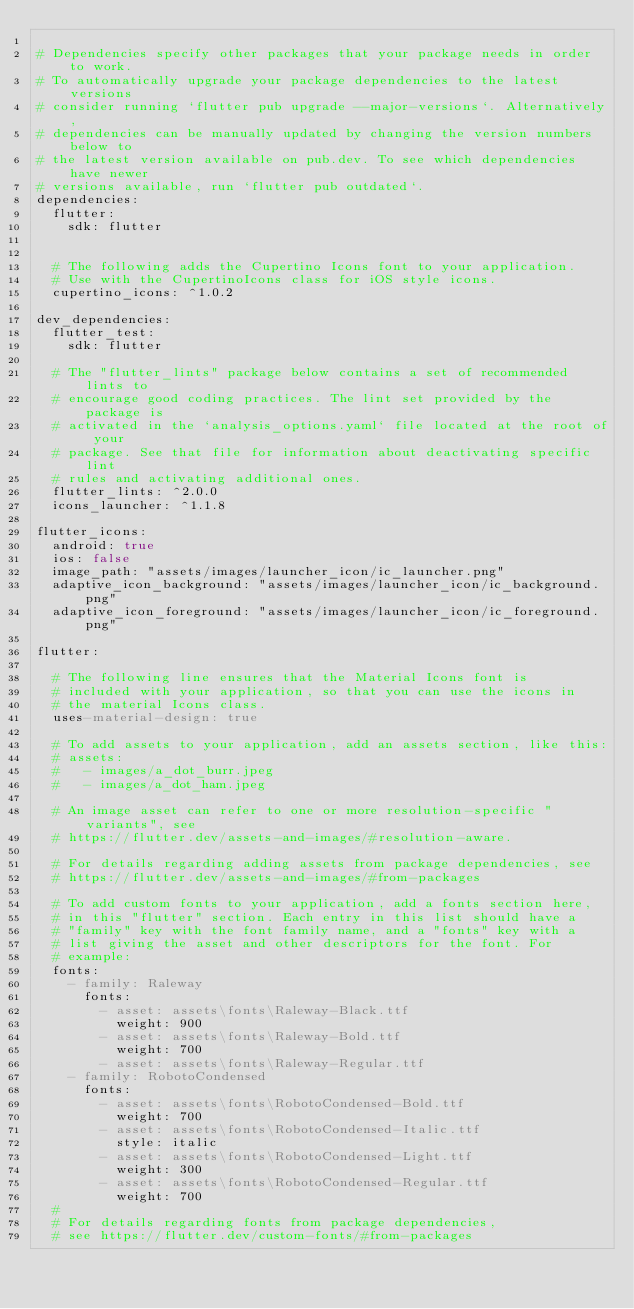Convert code to text. <code><loc_0><loc_0><loc_500><loc_500><_YAML_>
# Dependencies specify other packages that your package needs in order to work.
# To automatically upgrade your package dependencies to the latest versions
# consider running `flutter pub upgrade --major-versions`. Alternatively,
# dependencies can be manually updated by changing the version numbers below to
# the latest version available on pub.dev. To see which dependencies have newer
# versions available, run `flutter pub outdated`.
dependencies:
  flutter:
    sdk: flutter


  # The following adds the Cupertino Icons font to your application.
  # Use with the CupertinoIcons class for iOS style icons.
  cupertino_icons: ^1.0.2

dev_dependencies:
  flutter_test:
    sdk: flutter

  # The "flutter_lints" package below contains a set of recommended lints to
  # encourage good coding practices. The lint set provided by the package is
  # activated in the `analysis_options.yaml` file located at the root of your
  # package. See that file for information about deactivating specific lint
  # rules and activating additional ones.
  flutter_lints: ^2.0.0
  icons_launcher: ^1.1.8

flutter_icons:
  android: true
  ios: false
  image_path: "assets/images/launcher_icon/ic_launcher.png"
  adaptive_icon_background: "assets/images/launcher_icon/ic_background.png"
  adaptive_icon_foreground: "assets/images/launcher_icon/ic_foreground.png"

flutter:

  # The following line ensures that the Material Icons font is
  # included with your application, so that you can use the icons in
  # the material Icons class.
  uses-material-design: true

  # To add assets to your application, add an assets section, like this:
  # assets:
  #   - images/a_dot_burr.jpeg
  #   - images/a_dot_ham.jpeg

  # An image asset can refer to one or more resolution-specific "variants", see
  # https://flutter.dev/assets-and-images/#resolution-aware.

  # For details regarding adding assets from package dependencies, see
  # https://flutter.dev/assets-and-images/#from-packages

  # To add custom fonts to your application, add a fonts section here,
  # in this "flutter" section. Each entry in this list should have a
  # "family" key with the font family name, and a "fonts" key with a
  # list giving the asset and other descriptors for the font. For
  # example:
  fonts:
    - family: Raleway
      fonts:
        - asset: assets\fonts\Raleway-Black.ttf
          weight: 900
        - asset: assets\fonts\Raleway-Bold.ttf
          weight: 700
        - asset: assets\fonts\Raleway-Regular.ttf
    - family: RobotoCondensed
      fonts:
        - asset: assets\fonts\RobotoCondensed-Bold.ttf
          weight: 700
        - asset: assets\fonts\RobotoCondensed-Italic.ttf
          style: italic
        - asset: assets\fonts\RobotoCondensed-Light.ttf
          weight: 300
        - asset: assets\fonts\RobotoCondensed-Regular.ttf
          weight: 700
  #
  # For details regarding fonts from package dependencies,
  # see https://flutter.dev/custom-fonts/#from-packages
</code> 